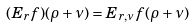Convert formula to latex. <formula><loc_0><loc_0><loc_500><loc_500>( E _ { r } f ) ( \rho + \nu ) = E _ { r , \nu } f ( \rho + \nu )</formula> 